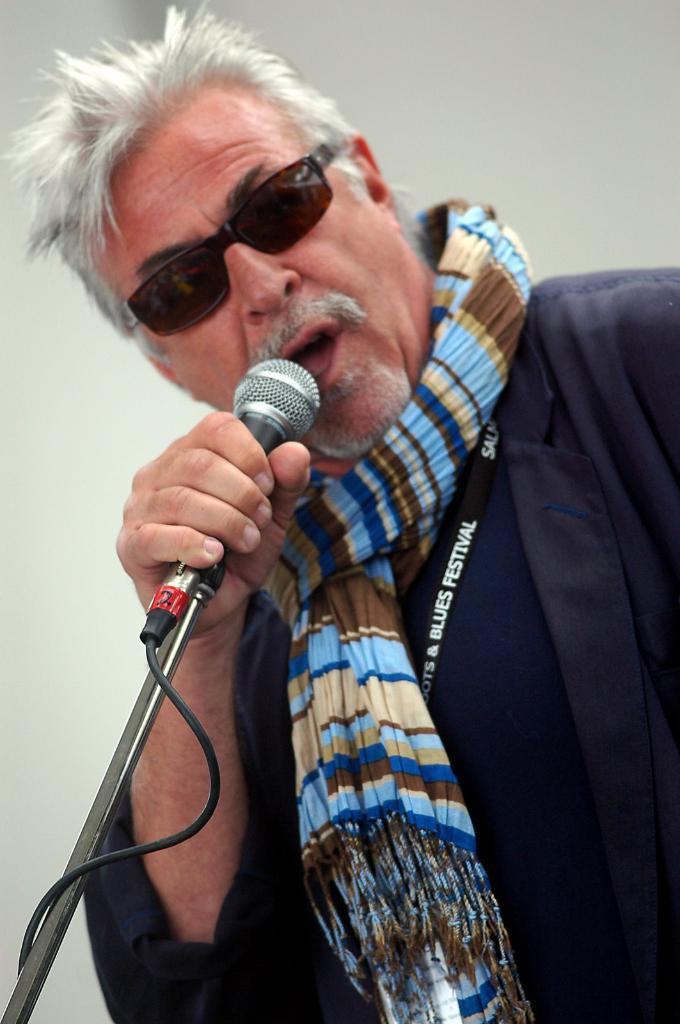In one or two sentences, can you explain what this image depicts? A man is singing with a mic in his hand. 